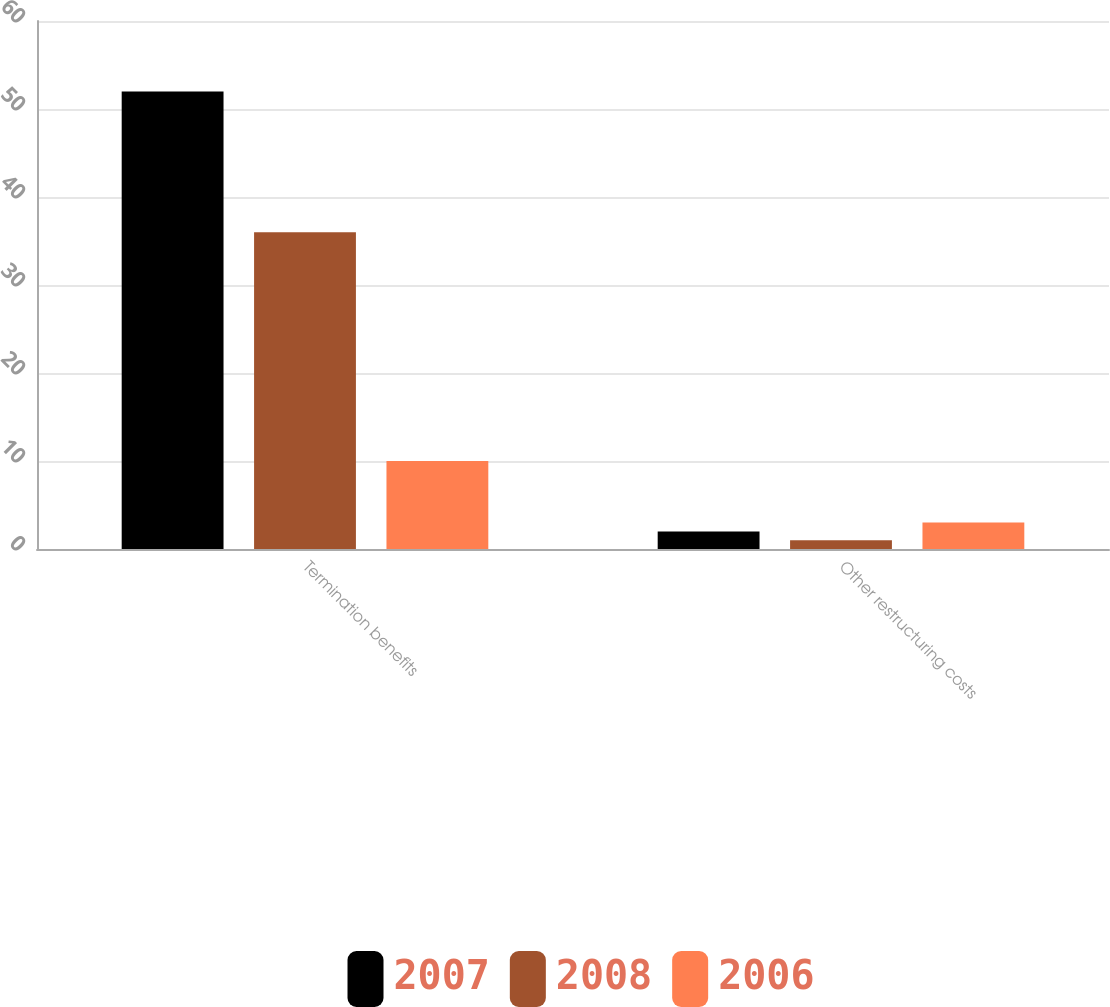Convert chart to OTSL. <chart><loc_0><loc_0><loc_500><loc_500><stacked_bar_chart><ecel><fcel>Termination benefits<fcel>Other restructuring costs<nl><fcel>2007<fcel>52<fcel>2<nl><fcel>2008<fcel>36<fcel>1<nl><fcel>2006<fcel>10<fcel>3<nl></chart> 